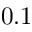Convert formula to latex. <formula><loc_0><loc_0><loc_500><loc_500>0 . 1</formula> 